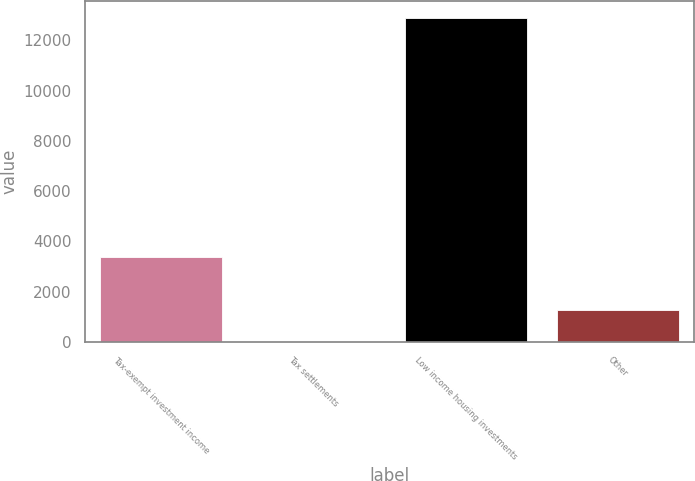Convert chart to OTSL. <chart><loc_0><loc_0><loc_500><loc_500><bar_chart><fcel>Tax-exempt investment income<fcel>Tax settlements<fcel>Low income housing investments<fcel>Other<nl><fcel>3371<fcel>1.87<fcel>12900<fcel>1291.68<nl></chart> 